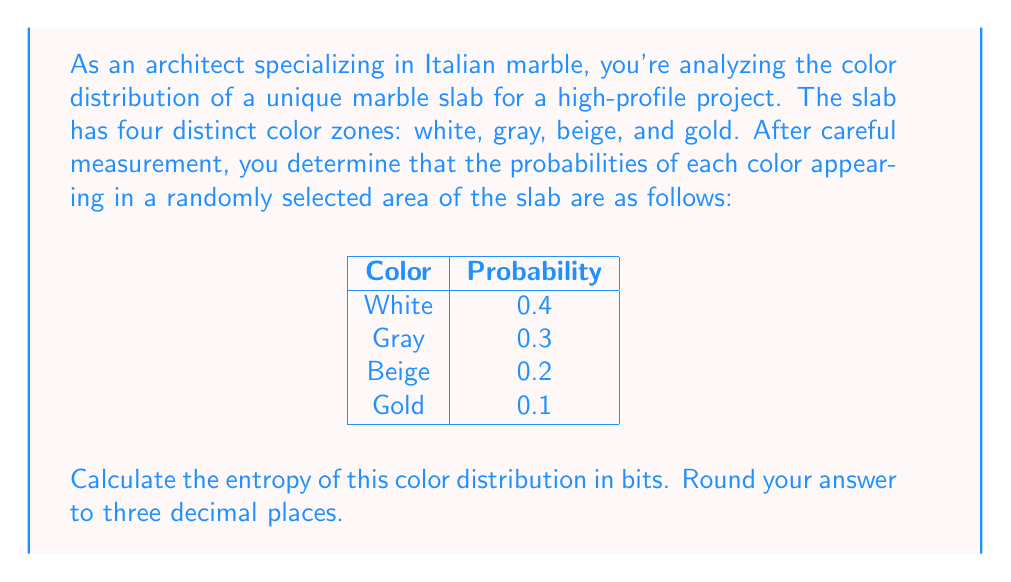Can you answer this question? To calculate the entropy of the color distribution, we'll use the formula for Shannon entropy:

$$H = -\sum_{i=1}^n p_i \log_2(p_i)$$

Where:
- $H$ is the entropy in bits
- $p_i$ is the probability of each color
- $n$ is the number of colors (in this case, 4)

Let's calculate each term:

1. For white (p = 0.4):
   $-0.4 \log_2(0.4) = 0.528321$

2. For gray (p = 0.3):
   $-0.3 \log_2(0.3) = 0.521061$

3. For beige (p = 0.2):
   $-0.2 \log_2(0.2) = 0.464386$

4. For gold (p = 0.1):
   $-0.1 \log_2(0.1) = 0.332193$

Now, we sum these values:

$$H = 0.528321 + 0.521061 + 0.464386 + 0.332193 = 1.845961$$

Rounding to three decimal places, we get 1.846 bits.
Answer: 1.846 bits 